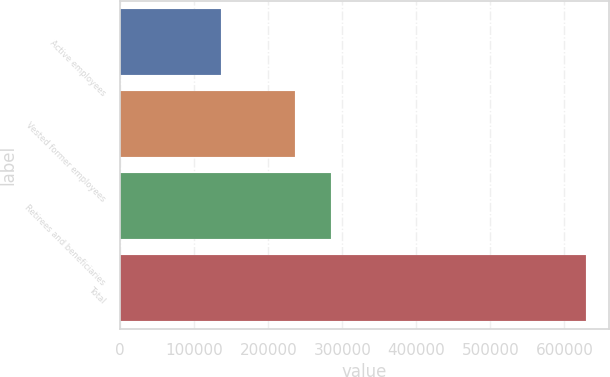Convert chart to OTSL. <chart><loc_0><loc_0><loc_500><loc_500><bar_chart><fcel>Active employees<fcel>Vested former employees<fcel>Retirees and beneficiaries<fcel>Total<nl><fcel>136000<fcel>236000<fcel>285300<fcel>629000<nl></chart> 